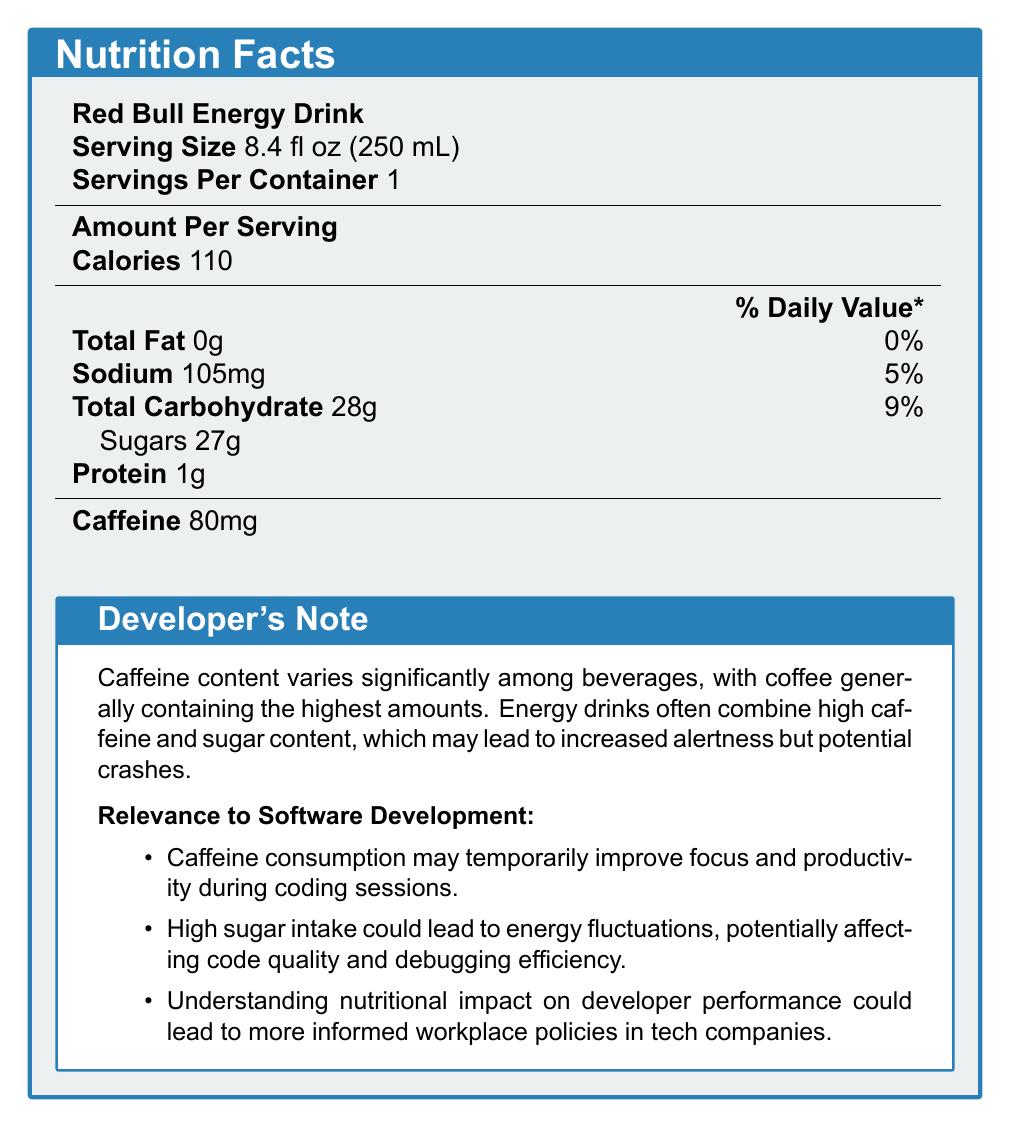What is the serving size of Red Bull Energy Drink? The serving size is explicitly stated in the document under the heading "Serving Size" for Red Bull Energy Drink.
Answer: 8.4 fl oz (250 mL) How much caffeine does Starbucks Pike Place Roast Coffee contain? This value is mentioned under the caffeine content for Starbucks Pike Place Roast Coffee in the document.
Answer: 310 mg Which beverage has the highest sugar content? Red Bull Energy Drink has 27g of sugar per serving, which is the highest among the drinks listed.
Answer: Red Bull Energy Drink What is the sodium content of Doritos Nacho Cheese Flavored Tortilla Chips per serving? The sodium content is specified in the document in the nutrition facts for Doritos Nacho Cheese Flavored Tortilla Chips.
Answer: 210 mg How many protein grams does the KIND Dark Chocolate Nuts & Sea Salt Bar contain? This value is provided in the nutrition facts for the KIND Dark Chocolate Nuts & Sea Salt Bar.
Answer: 6g Which of the following beverages has the least amount of calories? A. Red Bull Energy Drink B. Monster Energy Zero Ultra C. Starbucks Pike Place Roast Coffee Starbucks Pike Place Roast Coffee has 5 calories, which is the least among the options.
Answer: C Which beverage has the highest caffeine content per serving? A. Red Bull Energy Drink B. Monster Energy Zero Ultra C. Starbucks Pike Place Roast Coffee Starbucks Pike Place Roast Coffee has the highest caffeine content with 310 mg.
Answer: C Do KIND Dark Chocolate Nuts & Sea Salt Bars contain any caffeine? The document states that this snack has 0 mg of caffeine.
Answer: No Summarize the main insights provided by the document. The document includes nutritional facts for various beverages and snacks preferred by programmers, with a special emphasis on caffeine and sugar content. It also discusses their relevance to software development performance, emphasizing the importance of balanced nutrition.
Answer: The document provides detailed nutritional information about popular beverages and snacks for programmers, focusing on caffeine and sugar content. It highlights the significant variation in caffeine levels among beverages, noting that energy drinks and coffee have much higher caffeine content compared to snacks. The document also discusses the potential impact of these dietary choices on focus, productivity, and overall health in software development environments. What is the total carbohydrate content in a Clif Bar Chocolate Chip Energy Bar? This value is stated in the nutrition facts for the Clif Bar Chocolate Chip Energy Bar.
Answer: 45g Do the research notes mention anything about protein content in the snacks? The provided research notes do not specifically mention anything about protein content in the snacks.
Answer: No What percentage of the daily value of sodium does Monster Energy Zero Ultra provide? The document specifies the sodium content as 140 mg, which is 6% of the daily value.
Answer: 6% Is sugar content mentioned for Starbucks Pike Place Roast Coffee? The document lists the total carbohydrate and sugar content for Starbucks Pike Place Roast Coffee as zero grams.
Answer: No Which snack has the highest protein content? The Clif Bar Chocolate Chip Energy Bar contains 9g of protein, the highest among the snacks listed.
Answer: Clif Bar Chocolate Chip Energy Bar What is the relevance of caffeine consumption to software development? The document's research notes state that caffeine consumption can enhance focus and productivity, which is relevant to the work of software developers.
Answer: Caffeine consumption may temporarily improve focus and productivity during coding sessions. 